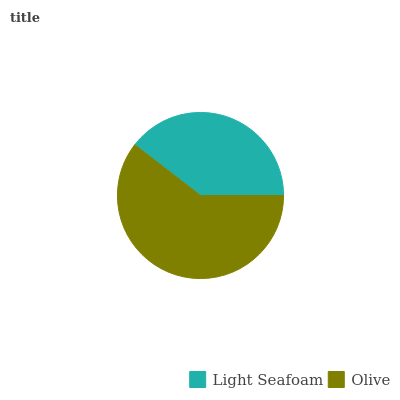Is Light Seafoam the minimum?
Answer yes or no. Yes. Is Olive the maximum?
Answer yes or no. Yes. Is Olive the minimum?
Answer yes or no. No. Is Olive greater than Light Seafoam?
Answer yes or no. Yes. Is Light Seafoam less than Olive?
Answer yes or no. Yes. Is Light Seafoam greater than Olive?
Answer yes or no. No. Is Olive less than Light Seafoam?
Answer yes or no. No. Is Olive the high median?
Answer yes or no. Yes. Is Light Seafoam the low median?
Answer yes or no. Yes. Is Light Seafoam the high median?
Answer yes or no. No. Is Olive the low median?
Answer yes or no. No. 